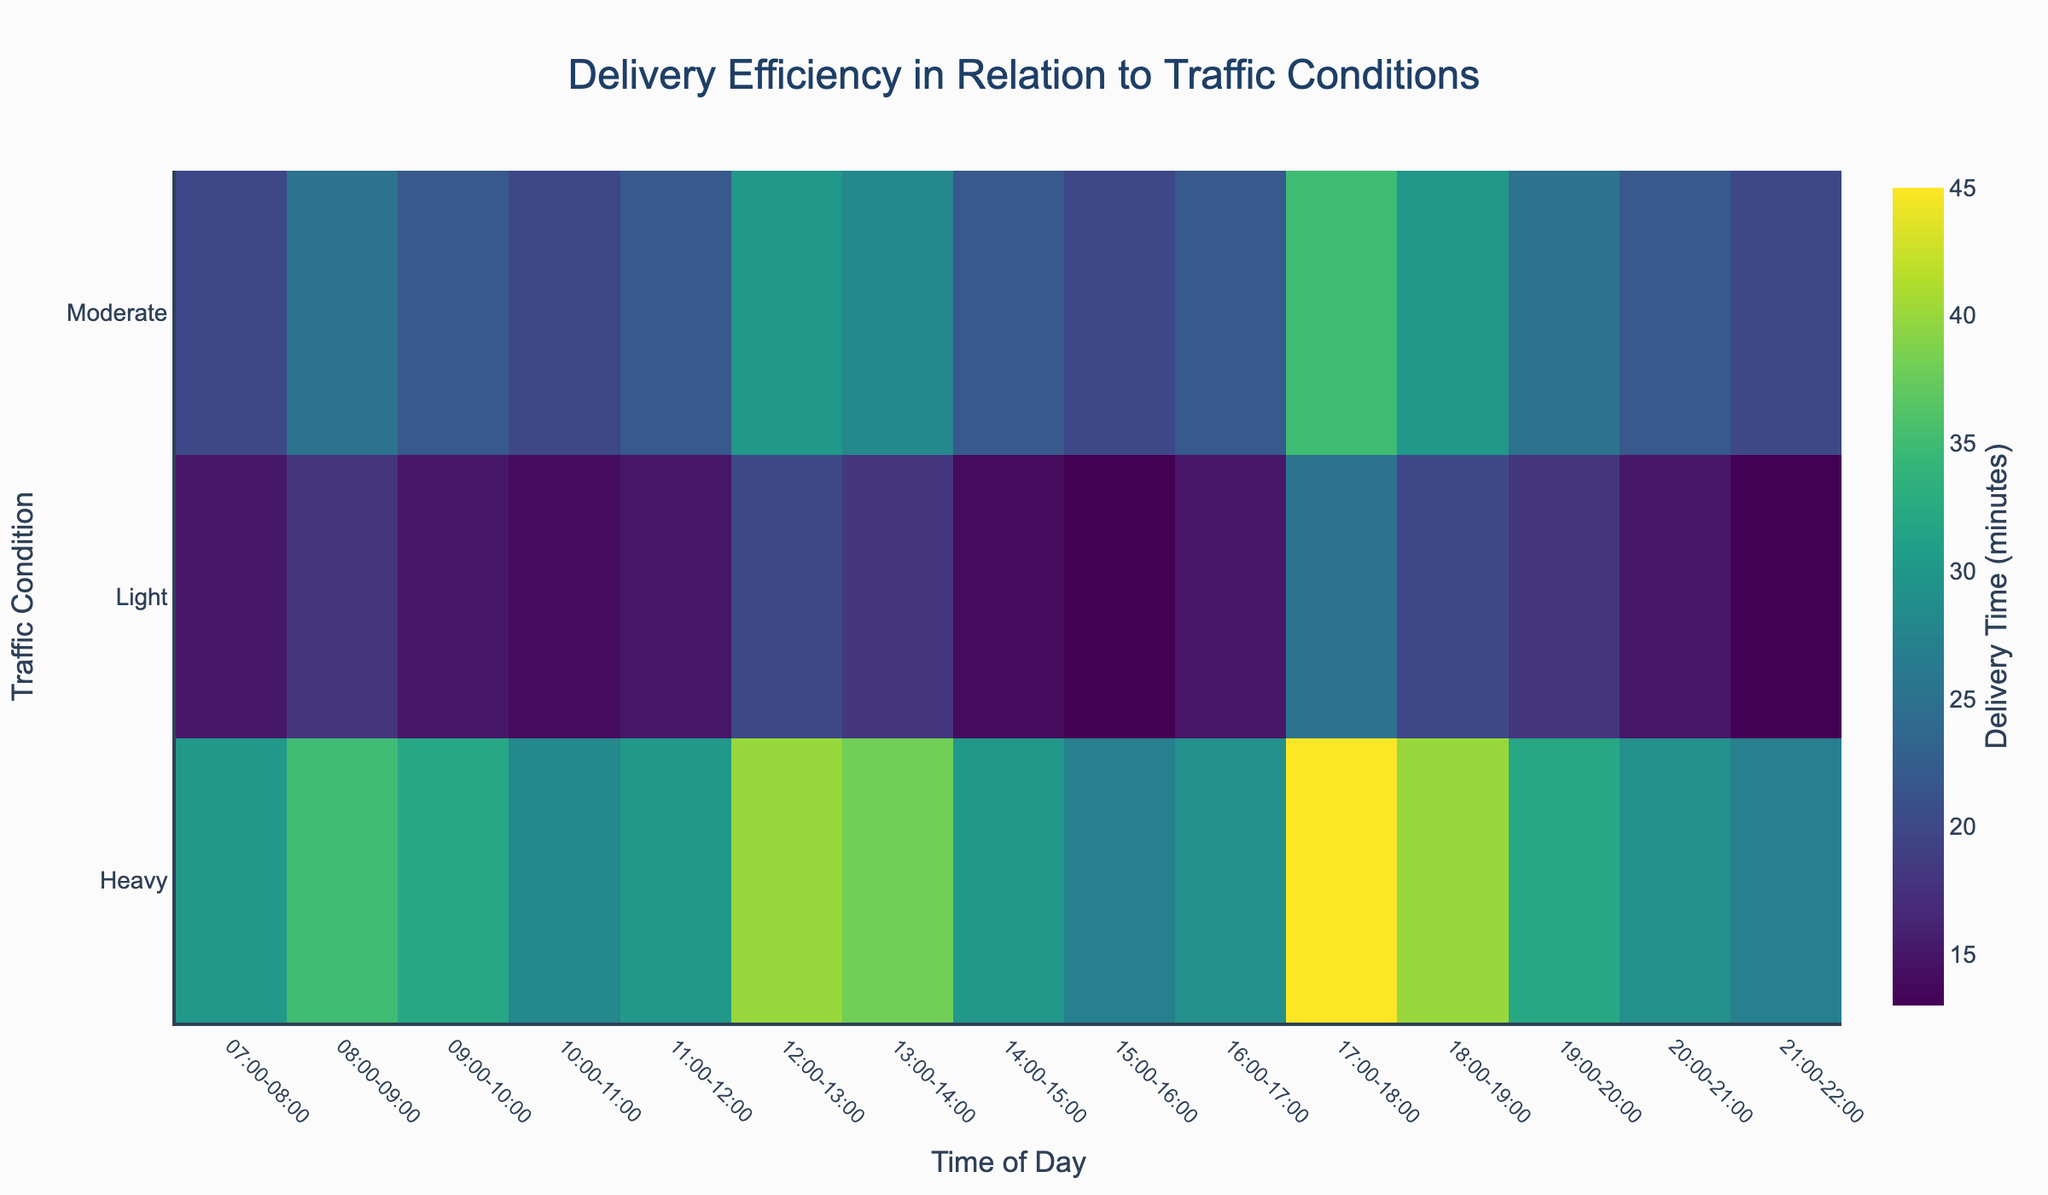What is the title of the heatmap? The title of the heatmap is usually positioned at the top of the figure. In this case, it is clearly indicated as "Delivery Efficiency in Relation to Traffic Conditions".
Answer: Delivery Efficiency in Relation to Traffic Conditions What is the color scale used in the heatmap? The color scale represents the range of delivery times, transitioning from lighter to darker shades as values increase. The name of the color scale is "Viridis".
Answer: Viridis How does delivery time change during the interval 17:00-18:00 for different traffic conditions? Look at the row corresponding to the time interval of 17:00-18:00 and observe the delivery times for Light, Moderate, and Heavy traffic conditions. The delivery times are 25, 35, and 45 minutes, respectively.
Answer: 25, 35, 45 minutes Which time interval has the highest delivery time for Light traffic condition? Scan through the row of Light traffic condition and identify the time interval with the darkest color. The time interval 17:00-18:00 has the delivery time of 25 minutes, the highest value in the row.
Answer: 17:00-18:00 What is the difference in delivery times between Light and Heavy traffic conditions from 08:00-09:00? Locate the delivery times for Light and Heavy traffic conditions in the 08:00-09:00 time interval. Subtract the Light traffic delivery time (18 minutes) from the Heavy traffic delivery time (35 minutes). The difference is 17 minutes.
Answer: 17 minutes At what time intervals do Light and Heavy traffic conditions have the same delivery time? Look for matching values across the Light and Heavy rows. Both 14:00-15:00 and 21:00-22:00 intervals have the same delivery time of 14 minutes and 27 minutes respectively.
Answer: 14:00-15:00, 21:00-22:00 What is the average delivery time taken during the 20:00-21:00 interval across all traffic conditions? Add the delivery times for Light, Moderate, and Heavy traffic conditions at 20:00-21:00 and divide by 3. The values are 15, 22, and 29 minutes, respectively. The average is (15 + 22 + 29)/3 = 22 minutes.
Answer: 22 minutes Which traffic condition shows the largest variation in delivery times throughout the day? Compare the range of delivery times for Light, Moderate, and Heavy traffic conditions. Light varies from 13 to 25 (12 minutes), Moderate from 20 to 35 (15 minutes), and Heavy from 27 to 45 (18 minutes). Heavy traffic condition shows the largest variation.
Answer: Heavy During which time interval does Moderate traffic typically have a delivery time greater than 25 minutes? Identify intervals in the Moderate traffic row where delivery times exceed 25 minutes. These intervals are 12:00-13:00 and 17:00-18:00, with delivery times of 30 and 35 minutes, respectively.
Answer: 12:00-13:00, 17:00-18:00 How does delivery time for Heavy traffic at 10:00-11:00 compare to Light traffic at 17:00-18:00? Check the delivery times for Heavy traffic at 10:00-11:00 (28 minutes) and Light traffic at 17:00-18:00 (25 minutes). Compare the numbers; 28 is greater than 25.
Answer: 28 minutes is greater 